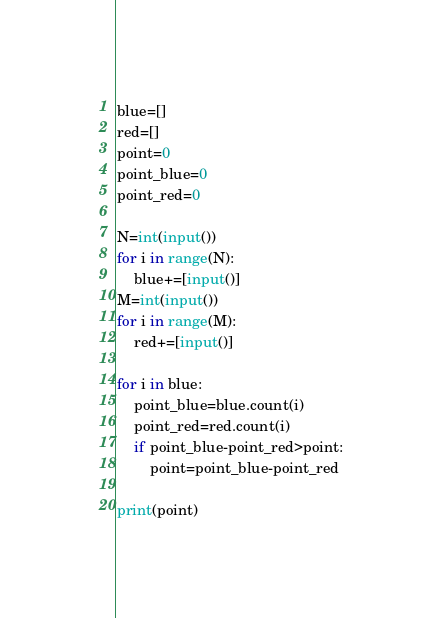<code> <loc_0><loc_0><loc_500><loc_500><_Python_>blue=[]
red=[]
point=0
point_blue=0
point_red=0

N=int(input())
for i in range(N):
    blue+=[input()]
M=int(input())
for i in range(M):
    red+=[input()]

for i in blue:
    point_blue=blue.count(i)
    point_red=red.count(i)
    if point_blue-point_red>point:
        point=point_blue-point_red

print(point)</code> 